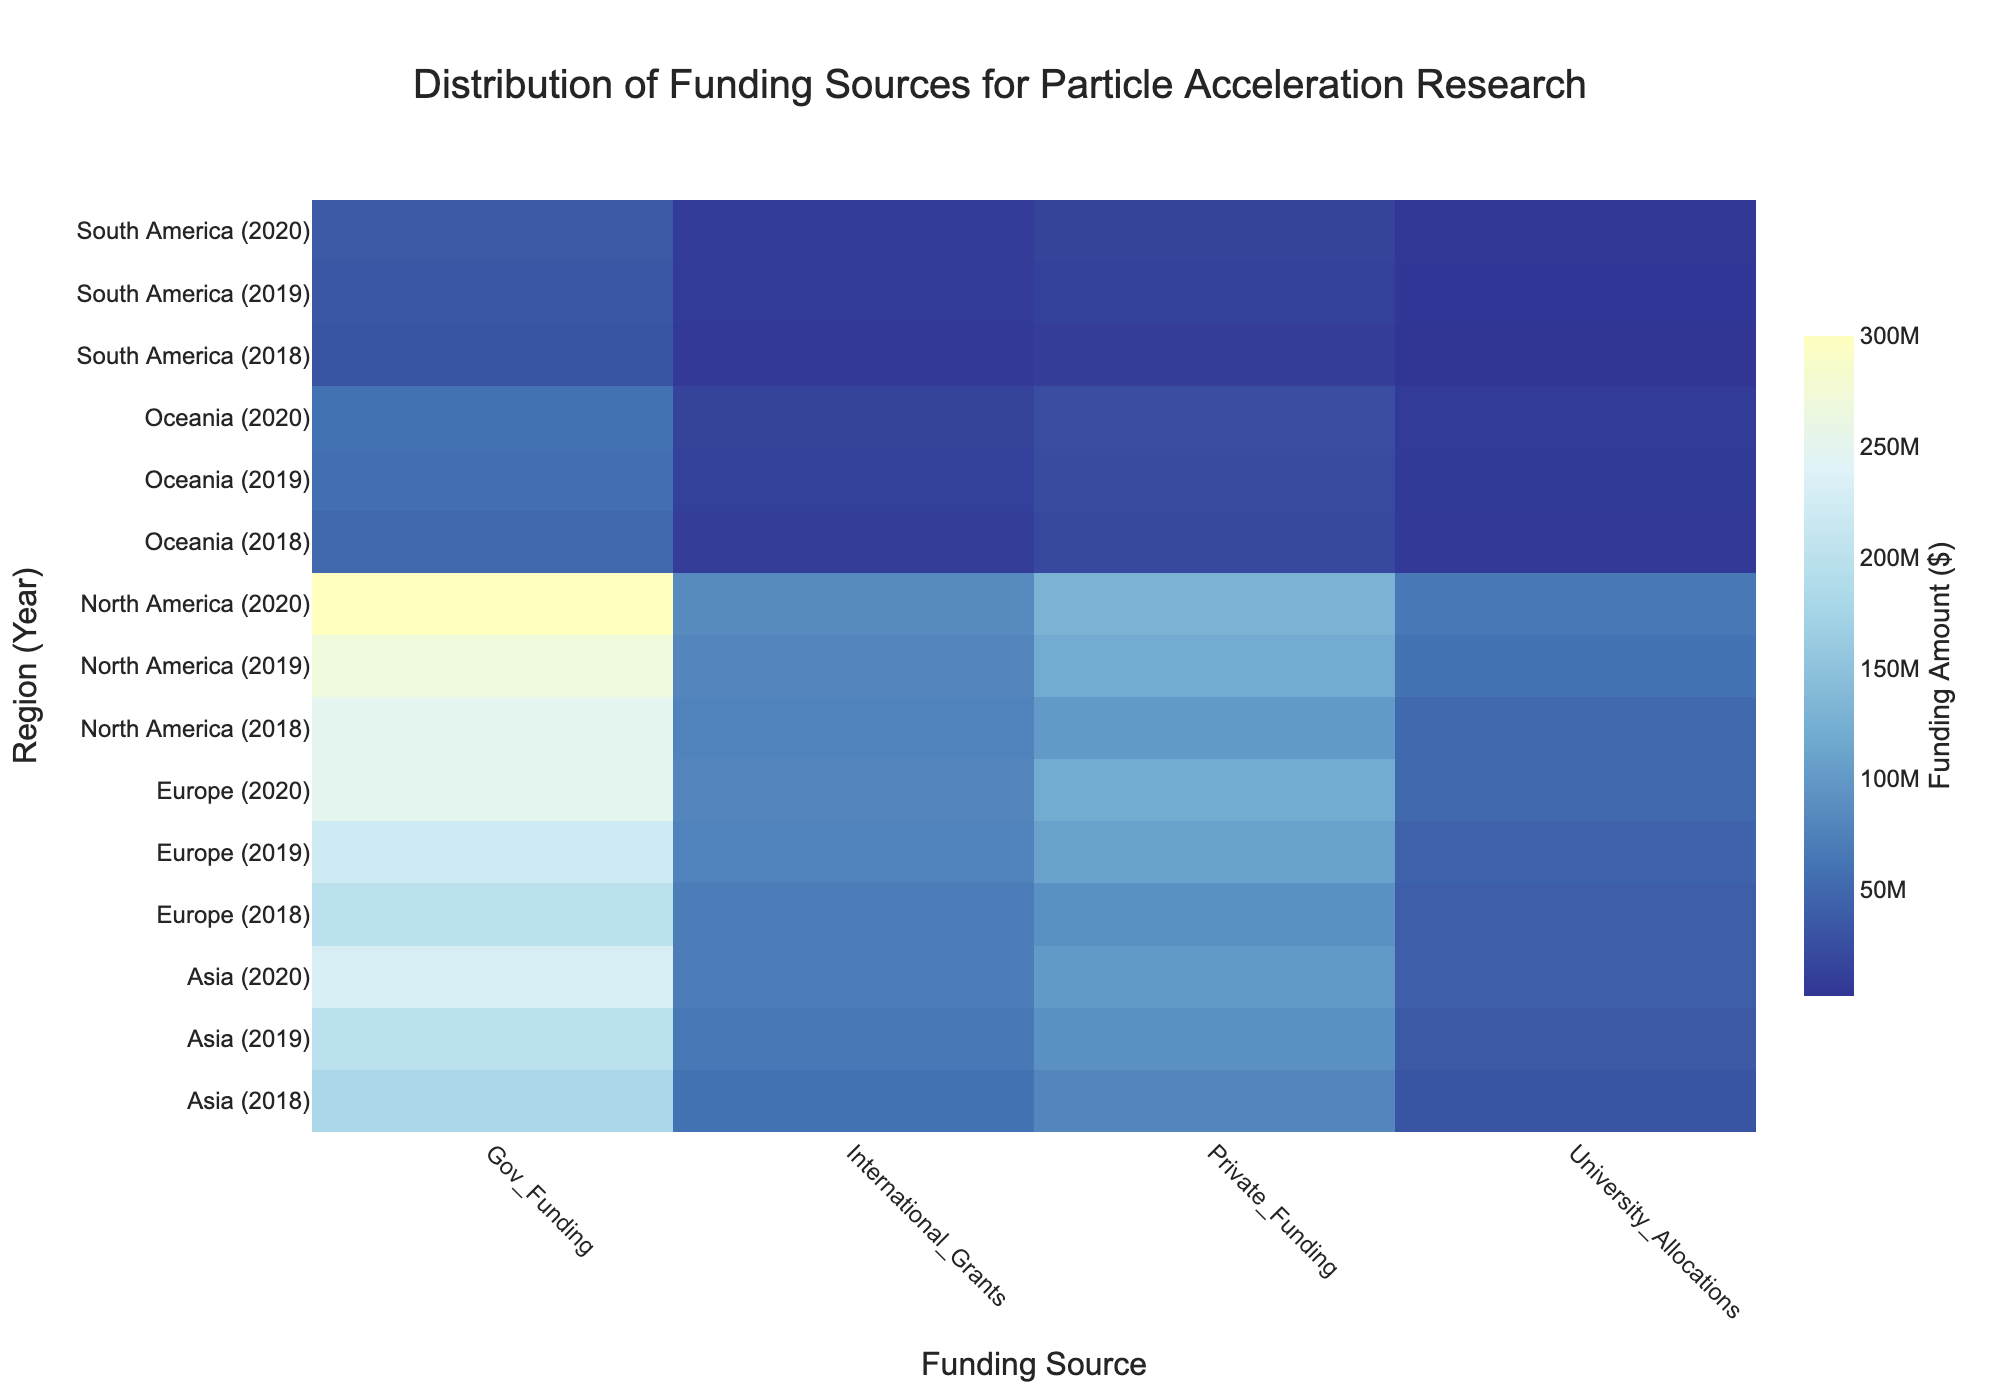What's the title of the figure? The title is usually prominently displayed at the top of the figure. This title helps users to understand the overall topic that the figure covers.
Answer: Distribution of Funding Sources for Particle Acceleration Research Which region had the highest government funding in 2020? Look at the 2020 data for each region and identify which has the highest amount under the "Government Funding" column. North America shows the highest government funding in this year.
Answer: North America What is the trend of international grants in Europe from 2018 to 2020? Observe the values of international grants in Europe across the three years. The values start at $70M in 2018, increase to $75M in 2019, and then reach $80M in 2020, indicating an increasing trend.
Answer: Increasing Which region had the lowest total funding in 2019? Sum up all types of funding (Gov_Funding, Private_Funding, International_Grants, University_Allocations) for each region in 2019 and determine which is the smallest. South America has the lowest total funding when all sources are summed.
Answer: South America How does private funding in Oceania in 2020 compare to that in North America in the same year? Compare the private funding amounts for these two regions in 2020. Oceania has $25M and North America has $130M, so Oceania's private funding is lower.
Answer: Lower in Oceania What's the highest university allocation observed in the 3-year period, and which region/year was it? Look through the university allocation values across all regions and years to find the maximum value. The highest is $65M in North America in 2020.
Answer: $65M, North America 2020 What is the average government funding in Asia from 2018 to 2020? Sum the government funding amounts in Asia for the three years and divide by 3. The government funding amounts are $180M, $200M, and $230M; summing these gives $610M, so the average is $610M/3.
Answer: $203.33M What stands out about South America's funding profile relative to other regions? By observing the heat map, note that South America's funding levels in every category are significantly lower compared to other regions. This is evident as South America's section of the heat map has consistently lighter shades.
Answer: Consistently lower funding Which year showed the highest increase in private funding across all regions? Compare the year-over-year change in private funding for all regions. Identify the year with the highest collective increase by summing the changes for each region. The overall highest increase is from 2019 to 2020.
Answer: 2019 to 2020 What patterns can you identify in North America's funding from 2018 to 2020? Observe the changes in funding across the different sources in North America over these years. Government funding, private funding, international grants, and university allocations all show an increasing trend.
Answer: Increasing trend across all sources 